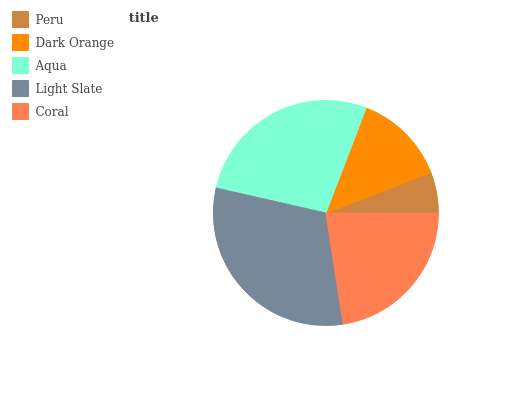Is Peru the minimum?
Answer yes or no. Yes. Is Light Slate the maximum?
Answer yes or no. Yes. Is Dark Orange the minimum?
Answer yes or no. No. Is Dark Orange the maximum?
Answer yes or no. No. Is Dark Orange greater than Peru?
Answer yes or no. Yes. Is Peru less than Dark Orange?
Answer yes or no. Yes. Is Peru greater than Dark Orange?
Answer yes or no. No. Is Dark Orange less than Peru?
Answer yes or no. No. Is Coral the high median?
Answer yes or no. Yes. Is Coral the low median?
Answer yes or no. Yes. Is Light Slate the high median?
Answer yes or no. No. Is Dark Orange the low median?
Answer yes or no. No. 